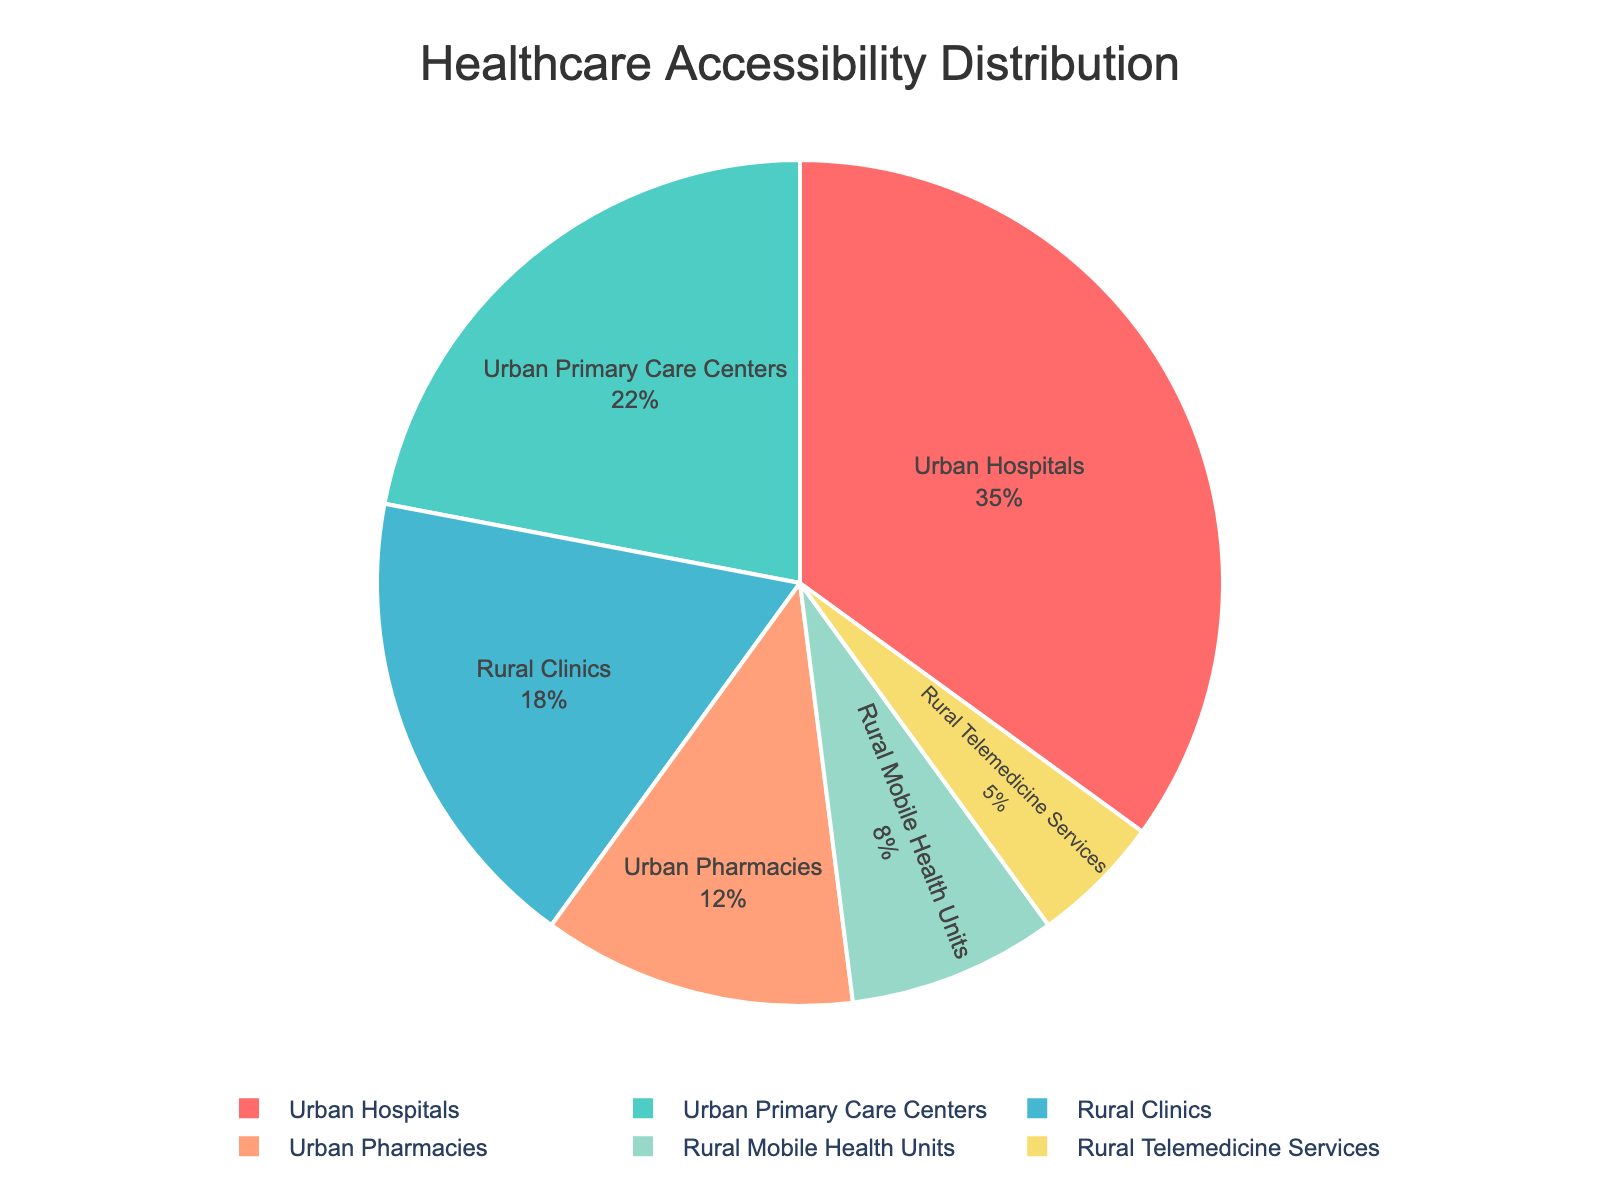What percentage of healthcare accessibility is provided by urban hospitals? The pie chart shows the percentage distribution of healthcare services, and we can directly see that urban hospitals contribute 35%.
Answer: 35% Which healthcare service provides the least accessibility in rural areas? By examining the pie chart, it's visible that rural telemedicine services provide the smallest portion, at 5%.
Answer: Rural telemedicine services How much more accessibility do urban hospitals provide compared to rural clinics? Urban hospitals provide 35%, and rural clinics provide 18%. The difference in accessibility is 35% - 18% = 17%.
Answer: 17% What is the combined percentage of urban primary care centers and rural mobile health units? Urban primary care centers contribute 22%, and rural mobile health units contribute 8%. The combined percentage is 22% + 8% = 30%.
Answer: 30% Which healthcare service has the second highest accessibility rate? Looking at the pie chart, urban hospitals have the highest at 35%, followed by urban primary care centers at 22%.
Answer: Urban primary care centers Compare the accessibility percentages between urban pharmacies and rural clinics. Which is greater and by how much? Urban pharmacies provide 12%, while rural clinics provide 18%. Rural clinics have a higher percentage by 18% - 12% = 6%.
Answer: Rural clinics by 6% How many different urban healthcare services are there compared to rural services? The chart shows urban healthcare services: hospitals, primary care centers, and pharmacies, totalling 3. Rural healthcare services include clinics, mobile health units, and telemedicine services, also totalling 3.
Answer: Equal (3 each) If we combine the percentages of all rural services, what proportion of healthcare accessibility do they represent? Rural clinics (18%), mobile health units (8%), and telemedicine services (5%). The total is 18% + 8% + 5% = 31%.
Answer: 31% If the total healthcare accessibility percentage must sum to 100%, verify this with the given data. Adding all the percentages: Urban Hospitals (35%) + Rural Clinics (18%) + Urban Primary Care Centers (22%) + Rural Mobile Health Units (8%) + Urban Pharmacies (12%) + Rural Telemedicine Services (5%) = 100%.
Answer: Correct (100%) 